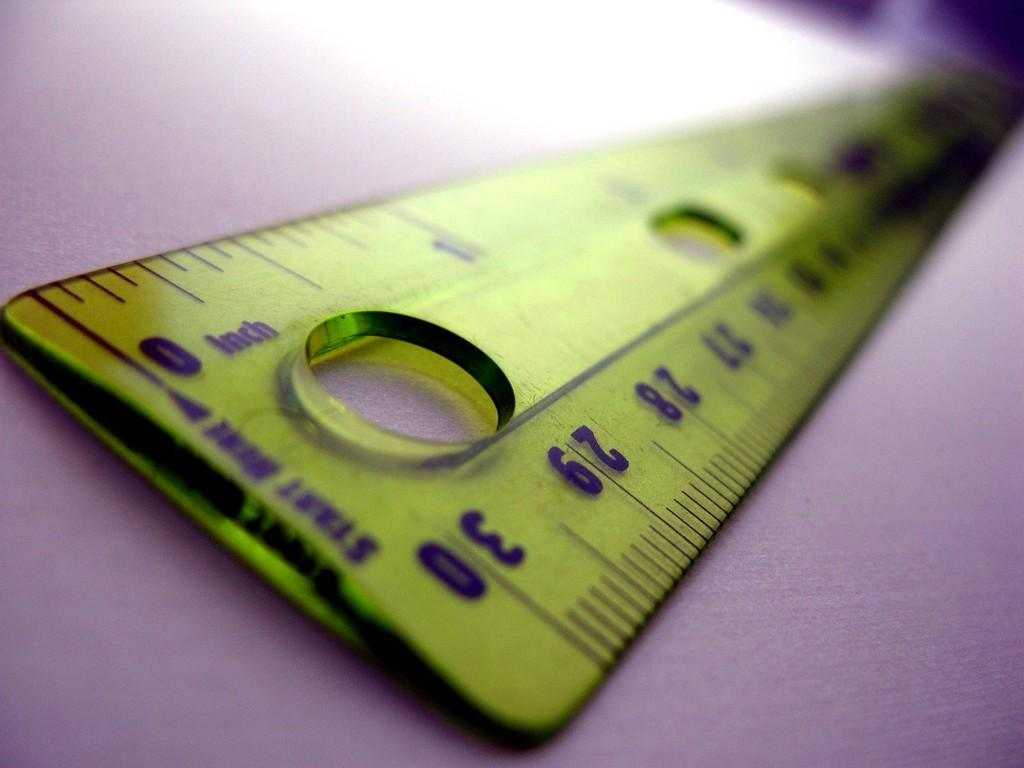<image>
Write a terse but informative summary of the picture. A yellow ruler says Start Here and has holes in it. 